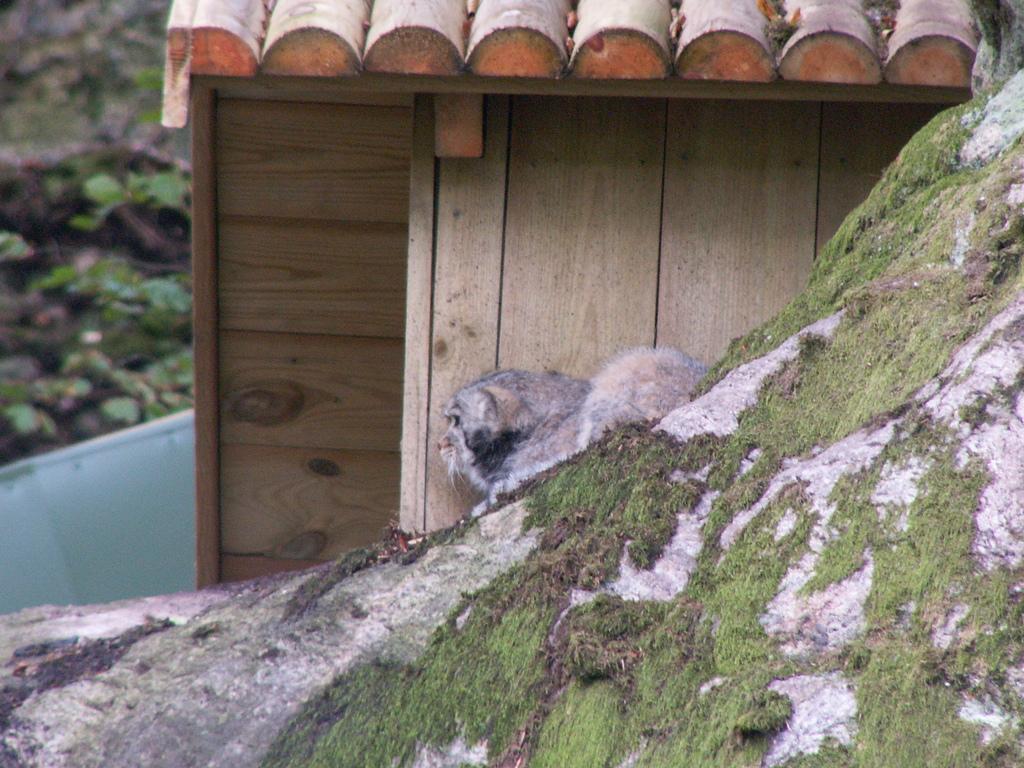Could you give a brief overview of what you see in this image? In this picture there is a dog in the center of the image, on a rock and there is a roof at the top side of the image. 